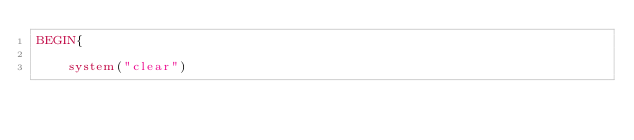Convert code to text. <code><loc_0><loc_0><loc_500><loc_500><_Awk_>BEGIN{

	system("clear")</code> 